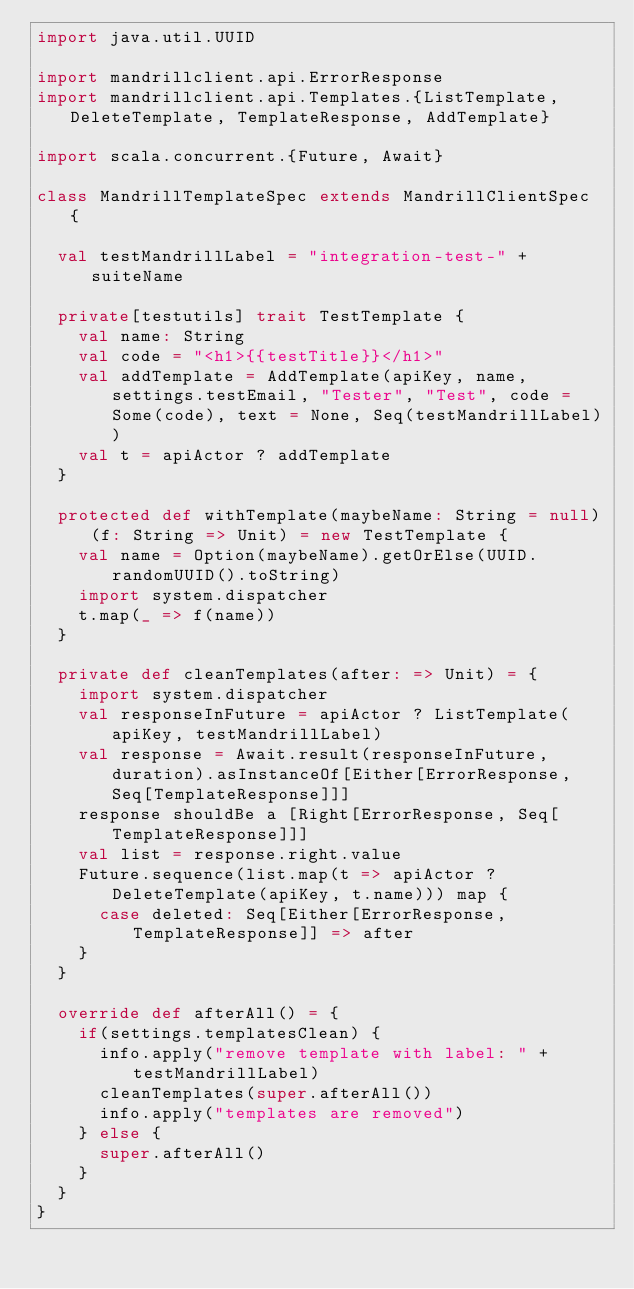Convert code to text. <code><loc_0><loc_0><loc_500><loc_500><_Scala_>import java.util.UUID

import mandrillclient.api.ErrorResponse
import mandrillclient.api.Templates.{ListTemplate, DeleteTemplate, TemplateResponse, AddTemplate}

import scala.concurrent.{Future, Await}

class MandrillTemplateSpec extends MandrillClientSpec {

  val testMandrillLabel = "integration-test-" + suiteName

  private[testutils] trait TestTemplate {
    val name: String
    val code = "<h1>{{testTitle}}</h1>"
    val addTemplate = AddTemplate(apiKey, name, settings.testEmail, "Tester", "Test", code = Some(code), text = None, Seq(testMandrillLabel))
    val t = apiActor ? addTemplate
  }

  protected def withTemplate(maybeName: String = null)(f: String => Unit) = new TestTemplate {
    val name = Option(maybeName).getOrElse(UUID.randomUUID().toString)
    import system.dispatcher
    t.map(_ => f(name))
  }

  private def cleanTemplates(after: => Unit) = {
    import system.dispatcher
    val responseInFuture = apiActor ? ListTemplate(apiKey, testMandrillLabel)
    val response = Await.result(responseInFuture, duration).asInstanceOf[Either[ErrorResponse, Seq[TemplateResponse]]]
    response shouldBe a [Right[ErrorResponse, Seq[TemplateResponse]]]
    val list = response.right.value
    Future.sequence(list.map(t => apiActor ? DeleteTemplate(apiKey, t.name))) map {
      case deleted: Seq[Either[ErrorResponse, TemplateResponse]] => after
    }
  }

  override def afterAll() = {
    if(settings.templatesClean) {
      info.apply("remove template with label: " + testMandrillLabel)
      cleanTemplates(super.afterAll())
      info.apply("templates are removed")
    } else {
      super.afterAll()
    }
  }
}
</code> 